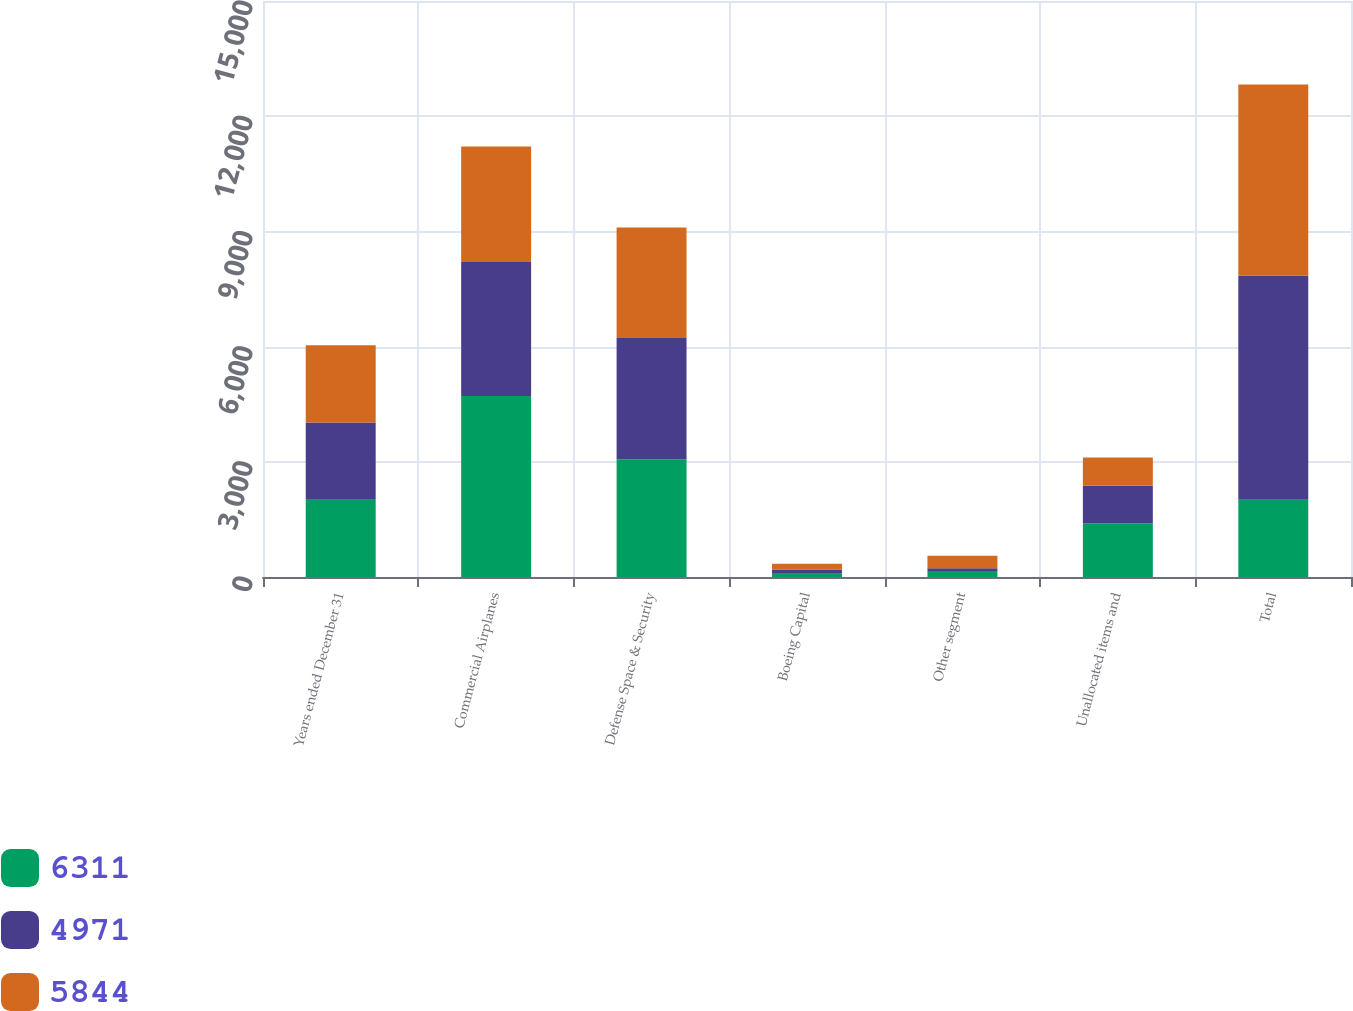Convert chart. <chart><loc_0><loc_0><loc_500><loc_500><stacked_bar_chart><ecel><fcel>Years ended December 31<fcel>Commercial Airplanes<fcel>Defense Space & Security<fcel>Boeing Capital<fcel>Other segment<fcel>Unallocated items and<fcel>Total<nl><fcel>6311<fcel>2012<fcel>4711<fcel>3068<fcel>82<fcel>159<fcel>1391<fcel>2010.5<nl><fcel>4971<fcel>2011<fcel>3495<fcel>3158<fcel>113<fcel>66<fcel>988<fcel>5844<nl><fcel>5844<fcel>2010<fcel>3006<fcel>2875<fcel>152<fcel>327<fcel>735<fcel>4971<nl></chart> 